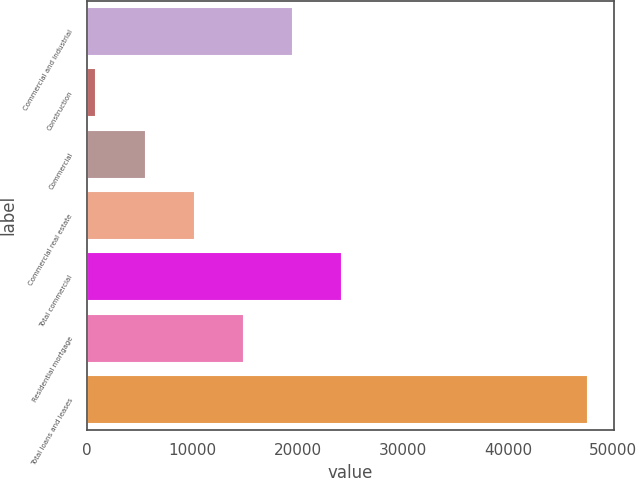Convert chart to OTSL. <chart><loc_0><loc_0><loc_500><loc_500><bar_chart><fcel>Commercial and industrial<fcel>Construction<fcel>Commercial<fcel>Commercial real estate<fcel>Total commercial<fcel>Residential mortgage<fcel>Total loans and leases<nl><fcel>19587.4<fcel>875<fcel>5553.1<fcel>10231.2<fcel>24265.5<fcel>14909.3<fcel>47656<nl></chart> 